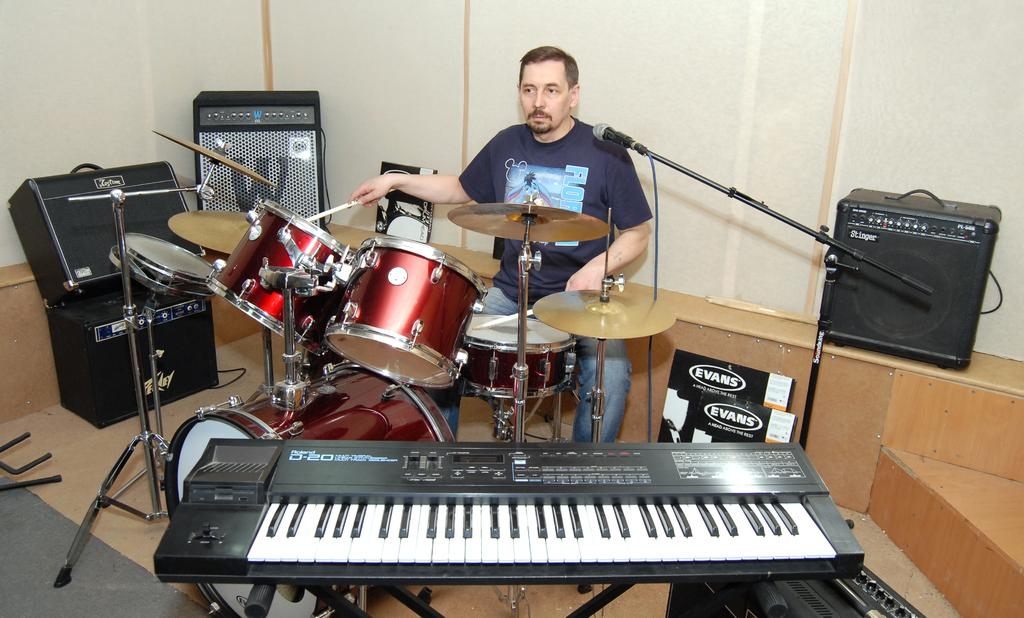Who is the main subject in the image? There is a man in the image. What is the man doing in the image? The man is sitting and playing a musical instrument. What can be seen in the background of the image? There is a wall in the background of the image. What type of club does the man belong to in the image? There is no indication in the image that the man belongs to any club. 